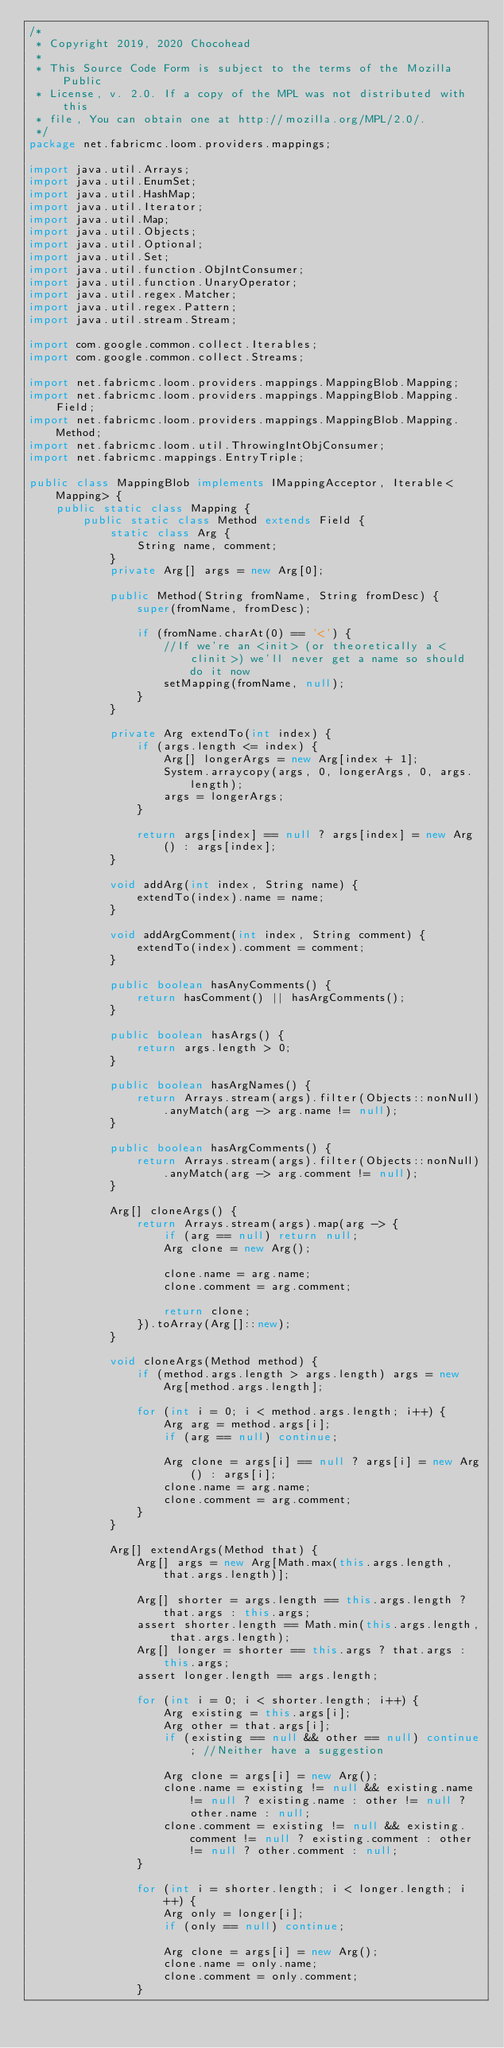<code> <loc_0><loc_0><loc_500><loc_500><_Java_>/*
 * Copyright 2019, 2020 Chocohead
 *
 * This Source Code Form is subject to the terms of the Mozilla Public
 * License, v. 2.0. If a copy of the MPL was not distributed with this
 * file, You can obtain one at http://mozilla.org/MPL/2.0/.
 */
package net.fabricmc.loom.providers.mappings;

import java.util.Arrays;
import java.util.EnumSet;
import java.util.HashMap;
import java.util.Iterator;
import java.util.Map;
import java.util.Objects;
import java.util.Optional;
import java.util.Set;
import java.util.function.ObjIntConsumer;
import java.util.function.UnaryOperator;
import java.util.regex.Matcher;
import java.util.regex.Pattern;
import java.util.stream.Stream;

import com.google.common.collect.Iterables;
import com.google.common.collect.Streams;

import net.fabricmc.loom.providers.mappings.MappingBlob.Mapping;
import net.fabricmc.loom.providers.mappings.MappingBlob.Mapping.Field;
import net.fabricmc.loom.providers.mappings.MappingBlob.Mapping.Method;
import net.fabricmc.loom.util.ThrowingIntObjConsumer;
import net.fabricmc.mappings.EntryTriple;

public class MappingBlob implements IMappingAcceptor, Iterable<Mapping> {
	public static class Mapping {
		public static class Method extends Field {
			static class Arg {
				String name, comment;
			}
			private Arg[] args = new Arg[0];

			public Method(String fromName, String fromDesc) {
				super(fromName, fromDesc);

				if (fromName.charAt(0) == '<') {
					//If we're an <init> (or theoretically a <clinit>) we'll never get a name so should do it now
					setMapping(fromName, null);
				}
			}

			private Arg extendTo(int index) {
				if (args.length <= index) {
					Arg[] longerArgs = new Arg[index + 1];
					System.arraycopy(args, 0, longerArgs, 0, args.length);
					args = longerArgs;
				}

				return args[index] == null ? args[index] = new Arg() : args[index];
			}

			void addArg(int index, String name) {
				extendTo(index).name = name;
			}

			void addArgComment(int index, String comment) {
				extendTo(index).comment = comment;
			}

			public boolean hasAnyComments() {
				return hasComment() || hasArgComments();
			}

			public boolean hasArgs() {
				return args.length > 0;
			}

			public boolean hasArgNames() {
				return Arrays.stream(args).filter(Objects::nonNull).anyMatch(arg -> arg.name != null);
			}

			public boolean hasArgComments() {
				return Arrays.stream(args).filter(Objects::nonNull).anyMatch(arg -> arg.comment != null);
			}

			Arg[] cloneArgs() {
				return Arrays.stream(args).map(arg -> {
					if (arg == null) return null;
					Arg clone = new Arg();

					clone.name = arg.name;
					clone.comment = arg.comment;

					return clone;
				}).toArray(Arg[]::new);
			}

			void cloneArgs(Method method) {
				if (method.args.length > args.length) args = new Arg[method.args.length];

				for (int i = 0; i < method.args.length; i++) {
					Arg arg = method.args[i];
					if (arg == null) continue;

					Arg clone = args[i] == null ? args[i] = new Arg() : args[i];
					clone.name = arg.name;
					clone.comment = arg.comment;
				}
			}

			Arg[] extendArgs(Method that) {
				Arg[] args = new Arg[Math.max(this.args.length, that.args.length)];

				Arg[] shorter = args.length == this.args.length ? that.args : this.args;
				assert shorter.length == Math.min(this.args.length, that.args.length);
				Arg[] longer = shorter == this.args ? that.args : this.args;
				assert longer.length == args.length;

				for (int i = 0; i < shorter.length; i++) {
					Arg existing = this.args[i];
					Arg other = that.args[i];
					if (existing == null && other == null) continue; //Neither have a suggestion

					Arg clone = args[i] = new Arg();
					clone.name = existing != null && existing.name != null ? existing.name : other != null ? other.name : null;
					clone.comment = existing != null && existing.comment != null ? existing.comment : other != null ? other.comment : null;
				}

				for (int i = shorter.length; i < longer.length; i++) {
					Arg only = longer[i];
					if (only == null) continue;

					Arg clone = args[i] = new Arg();
					clone.name = only.name;
					clone.comment = only.comment;
				}
</code> 